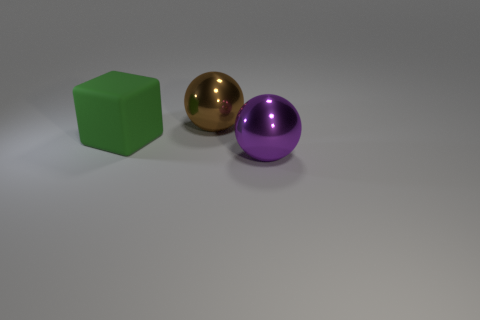Add 3 small cyan metal blocks. How many objects exist? 6 Subtract all blocks. How many objects are left? 2 Add 3 purple metallic things. How many purple metallic things are left? 4 Add 3 big purple matte objects. How many big purple matte objects exist? 3 Subtract 0 gray cylinders. How many objects are left? 3 Subtract all large brown shiny balls. Subtract all big brown shiny things. How many objects are left? 1 